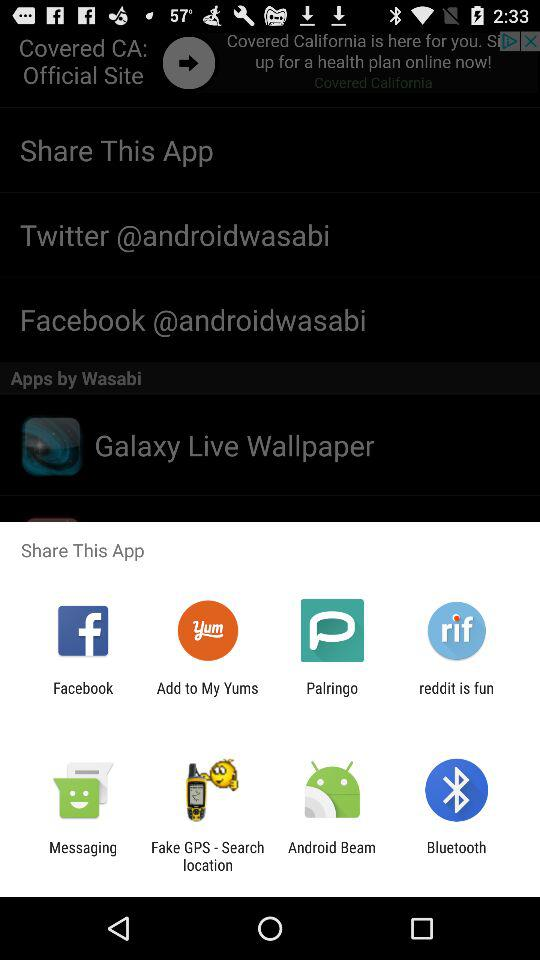Who is this application powered by?
When the provided information is insufficient, respond with <no answer>. <no answer> 